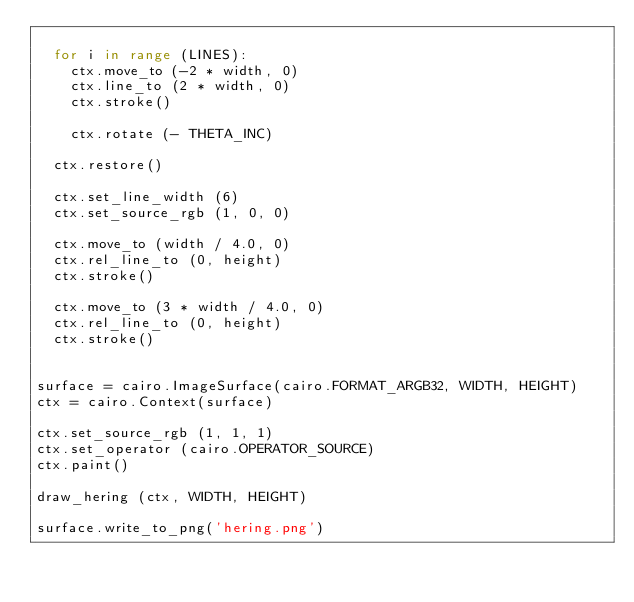Convert code to text. <code><loc_0><loc_0><loc_500><loc_500><_Python_>
  for i in range (LINES):
    ctx.move_to (-2 * width, 0)
    ctx.line_to (2 * width, 0)
    ctx.stroke()

    ctx.rotate (- THETA_INC)

  ctx.restore()

  ctx.set_line_width (6)
  ctx.set_source_rgb (1, 0, 0)

  ctx.move_to (width / 4.0, 0)
  ctx.rel_line_to (0, height)
  ctx.stroke()

  ctx.move_to (3 * width / 4.0, 0)
  ctx.rel_line_to (0, height)
  ctx.stroke()


surface = cairo.ImageSurface(cairo.FORMAT_ARGB32, WIDTH, HEIGHT)
ctx = cairo.Context(surface)

ctx.set_source_rgb (1, 1, 1)
ctx.set_operator (cairo.OPERATOR_SOURCE)
ctx.paint()

draw_hering (ctx, WIDTH, HEIGHT)

surface.write_to_png('hering.png')
</code> 